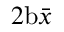Convert formula to latex. <formula><loc_0><loc_0><loc_500><loc_500>2 b \bar { x }</formula> 